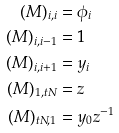<formula> <loc_0><loc_0><loc_500><loc_500>( M ) _ { i , i } & = \phi _ { i } \\ ( M ) _ { i , i - 1 } & = 1 \\ ( M ) _ { i , i + 1 } & = y _ { i } \\ ( M ) _ { 1 , t N } & = z \\ ( M ) _ { t N , 1 } & = y _ { 0 } z ^ { - 1 }</formula> 